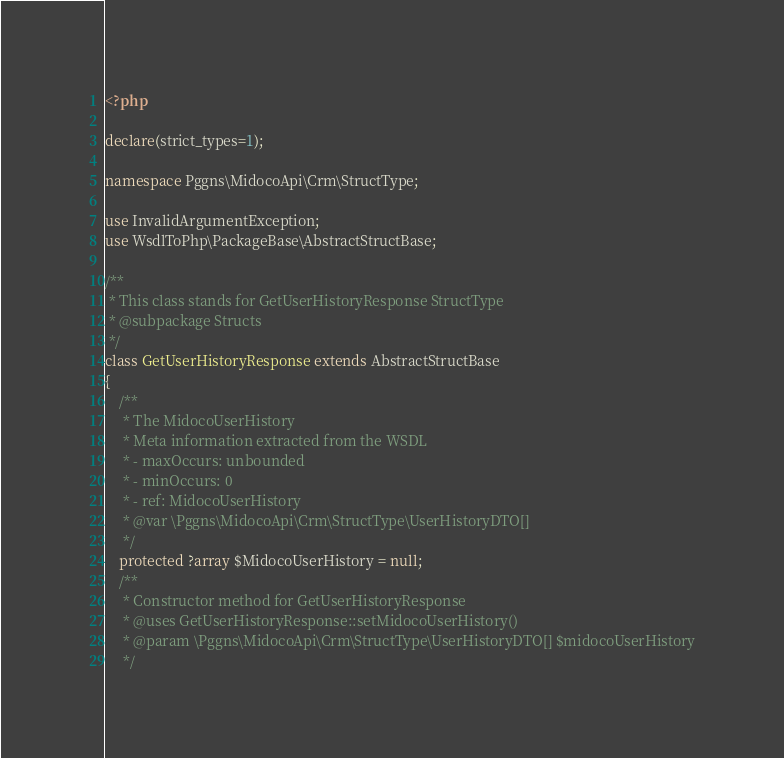Convert code to text. <code><loc_0><loc_0><loc_500><loc_500><_PHP_><?php

declare(strict_types=1);

namespace Pggns\MidocoApi\Crm\StructType;

use InvalidArgumentException;
use WsdlToPhp\PackageBase\AbstractStructBase;

/**
 * This class stands for GetUserHistoryResponse StructType
 * @subpackage Structs
 */
class GetUserHistoryResponse extends AbstractStructBase
{
    /**
     * The MidocoUserHistory
     * Meta information extracted from the WSDL
     * - maxOccurs: unbounded
     * - minOccurs: 0
     * - ref: MidocoUserHistory
     * @var \Pggns\MidocoApi\Crm\StructType\UserHistoryDTO[]
     */
    protected ?array $MidocoUserHistory = null;
    /**
     * Constructor method for GetUserHistoryResponse
     * @uses GetUserHistoryResponse::setMidocoUserHistory()
     * @param \Pggns\MidocoApi\Crm\StructType\UserHistoryDTO[] $midocoUserHistory
     */</code> 